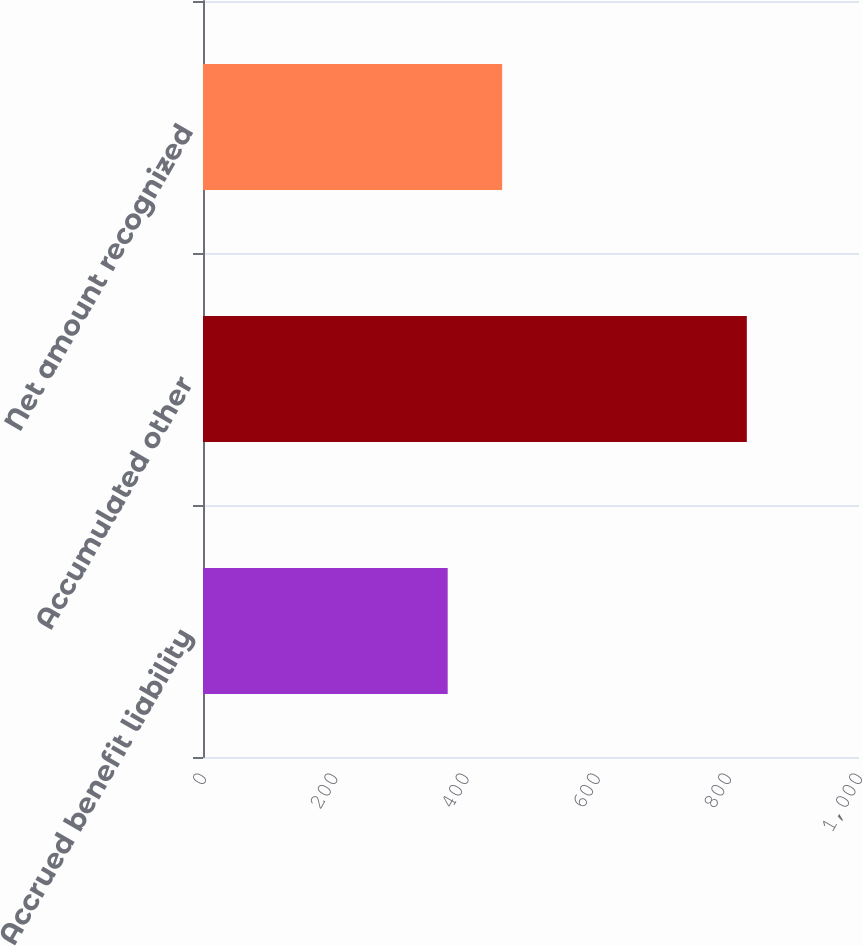Convert chart to OTSL. <chart><loc_0><loc_0><loc_500><loc_500><bar_chart><fcel>Accrued benefit liability<fcel>Accumulated other<fcel>Net amount recognized<nl><fcel>373<fcel>829<fcel>456<nl></chart> 